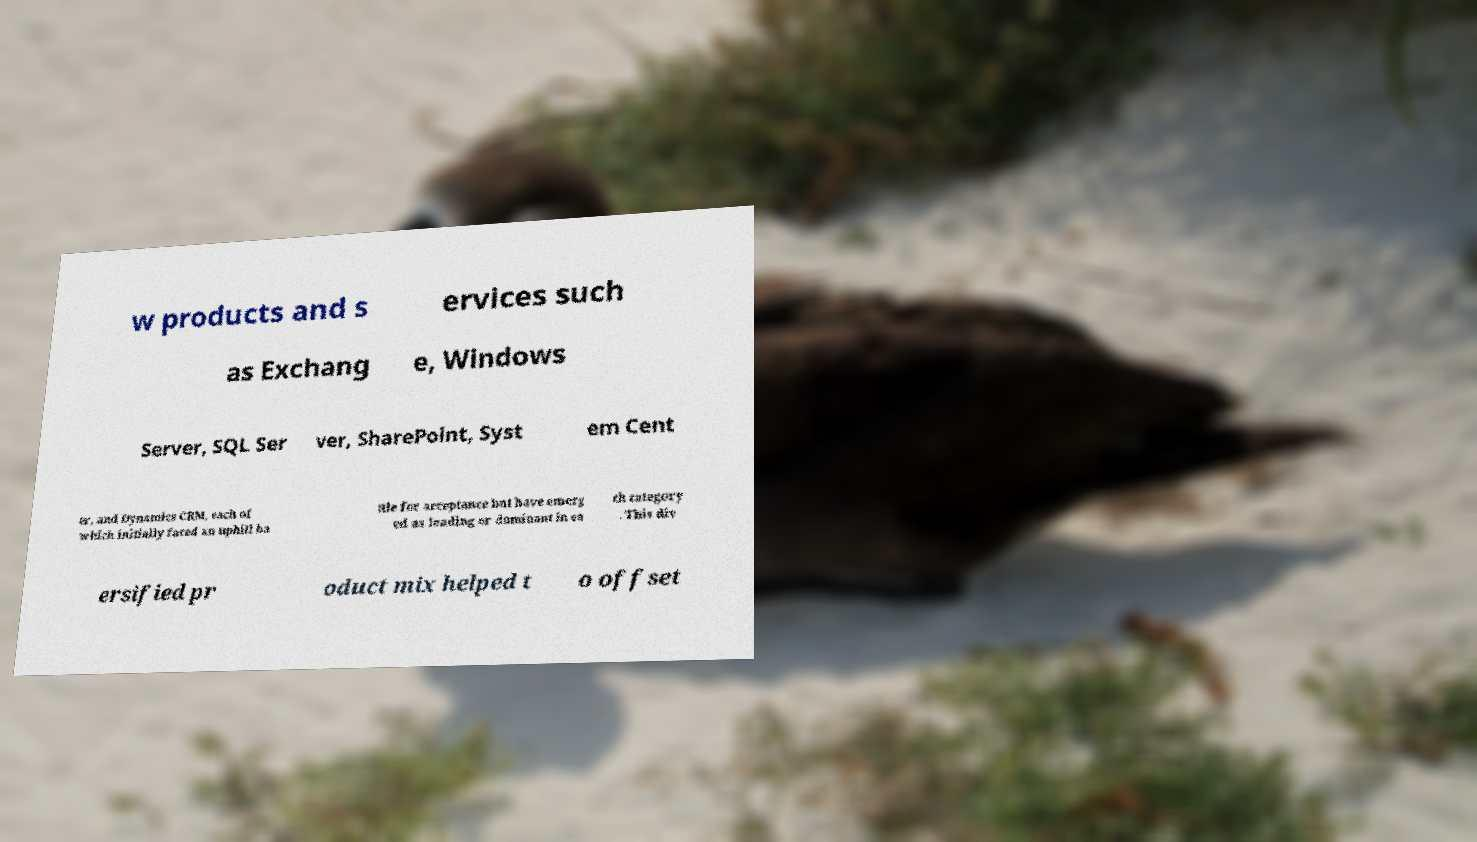Please identify and transcribe the text found in this image. w products and s ervices such as Exchang e, Windows Server, SQL Ser ver, SharePoint, Syst em Cent er, and Dynamics CRM, each of which initially faced an uphill ba ttle for acceptance but have emerg ed as leading or dominant in ea ch category . This div ersified pr oduct mix helped t o offset 